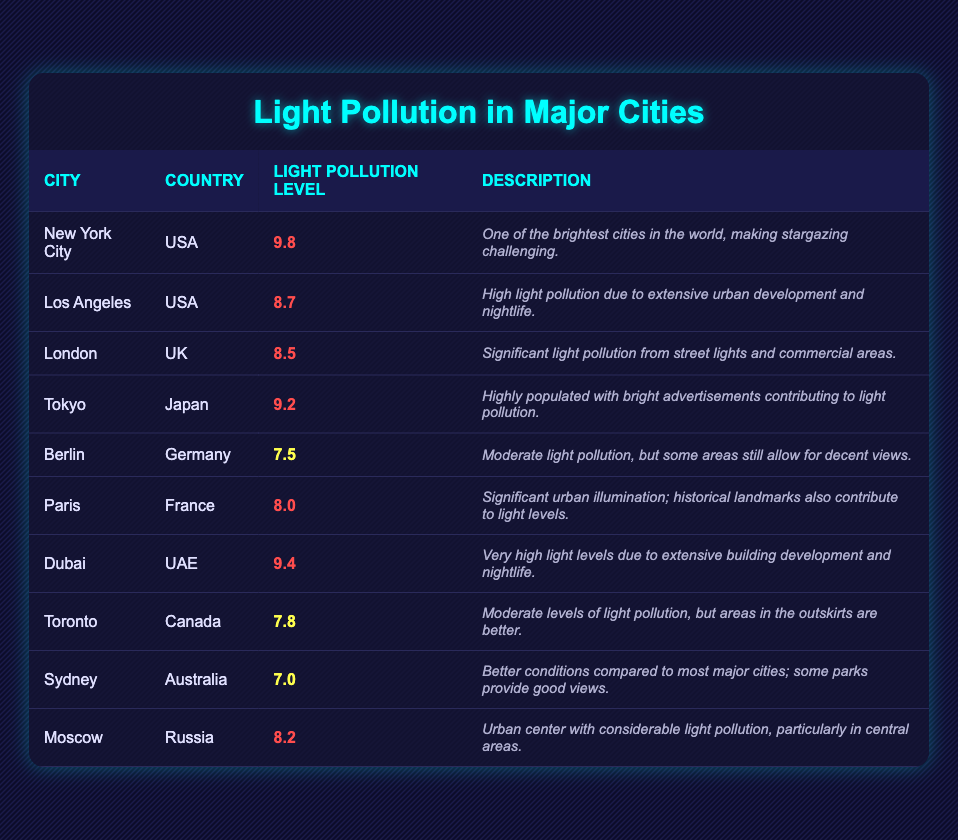What city has the highest average light pollution level? By examining the "Light Pollution Level" column, we can see that New York City has the highest average light pollution level at 9.8, which is greater than all other values in that column.
Answer: New York City Which city has a lower light pollution level, Berlin or Toronto? Comparing the light pollution levels, Berlin has an average level of 7.5 while Toronto has 7.8. Since 7.5 is less than 7.8, Berlin has a lower level of light pollution.
Answer: Berlin What is the average light pollution level of the cities listed in the table? To find the average, first add all the light pollution levels: 9.8 + 8.7 + 8.5 + 9.2 + 7.5 + 8.0 + 9.4 + 7.8 + 7.0 + 8.2 = 78.1. Then divide by the number of cities, which is 10. So, the average is 78.1 / 10 = 7.81.
Answer: 7.81 Is the average light pollution level in Sydney higher than in Paris? Sydney's average light pollution level is 7.0, while Paris's is 8.0. Since 7.0 is not greater than 8.0, we conclude that Sydney does not have a higher average level than Paris.
Answer: No Which two cities have light pollution levels in the medium range (6-8)? From the table, Berlin (7.5), Toronto (7.8), and Sydney (7.0) fall within this range. The two with the highest values in the medium range are Toronto and Berlin.
Answer: Toronto and Berlin How many cities have a light pollution level above 9? Looking through the table, New York City (9.8), Tokyo (9.2), and Dubai (9.4) have levels above 9. We count a total of 3 cities.
Answer: 3 Is the claim true or false that Los Angeles has a lower light pollution level than Moscow? Los Angeles has a light pollution level of 8.7 and Moscow has 8.2. Since 8.7 is greater than 8.2, the claim is false.
Answer: False Which city and country combination has a description that mentions extensive building development? By reviewing the descriptions, "Dubai, UAE" specifically mentions very high light levels due to extensive building development and nightlife.
Answer: Dubai, UAE What is the difference in light pollution levels between New York City and Berlin? New York City has an average light pollution level of 9.8, while Berlin's level is 7.5. The difference is calculated by subtracting Berlin's level from New York City's: 9.8 - 7.5 = 2.3.
Answer: 2.3 List all cities with an average light pollution level below 8 By examining the table, the cities below 8 are Berlin (7.5), Toronto (7.8), and Sydney (7.0). Thus, the complete list includes these three cities.
Answer: Berlin, Toronto, Sydney 